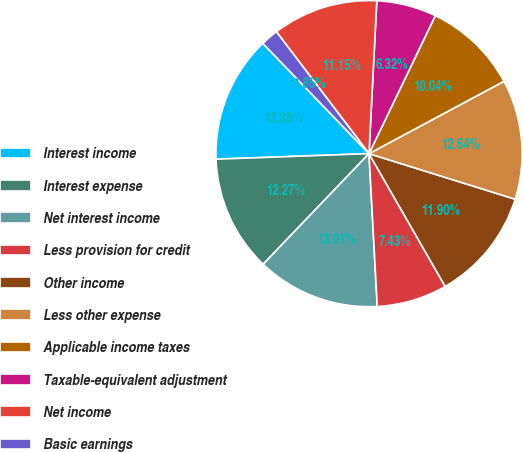Convert chart. <chart><loc_0><loc_0><loc_500><loc_500><pie_chart><fcel>Interest income<fcel>Interest expense<fcel>Net interest income<fcel>Less provision for credit<fcel>Other income<fcel>Less other expense<fcel>Applicable income taxes<fcel>Taxable-equivalent adjustment<fcel>Net income<fcel>Basic earnings<nl><fcel>13.38%<fcel>12.27%<fcel>13.01%<fcel>7.43%<fcel>11.9%<fcel>12.64%<fcel>10.04%<fcel>6.32%<fcel>11.15%<fcel>1.86%<nl></chart> 